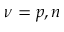Convert formula to latex. <formula><loc_0><loc_0><loc_500><loc_500>\nu = p , n</formula> 